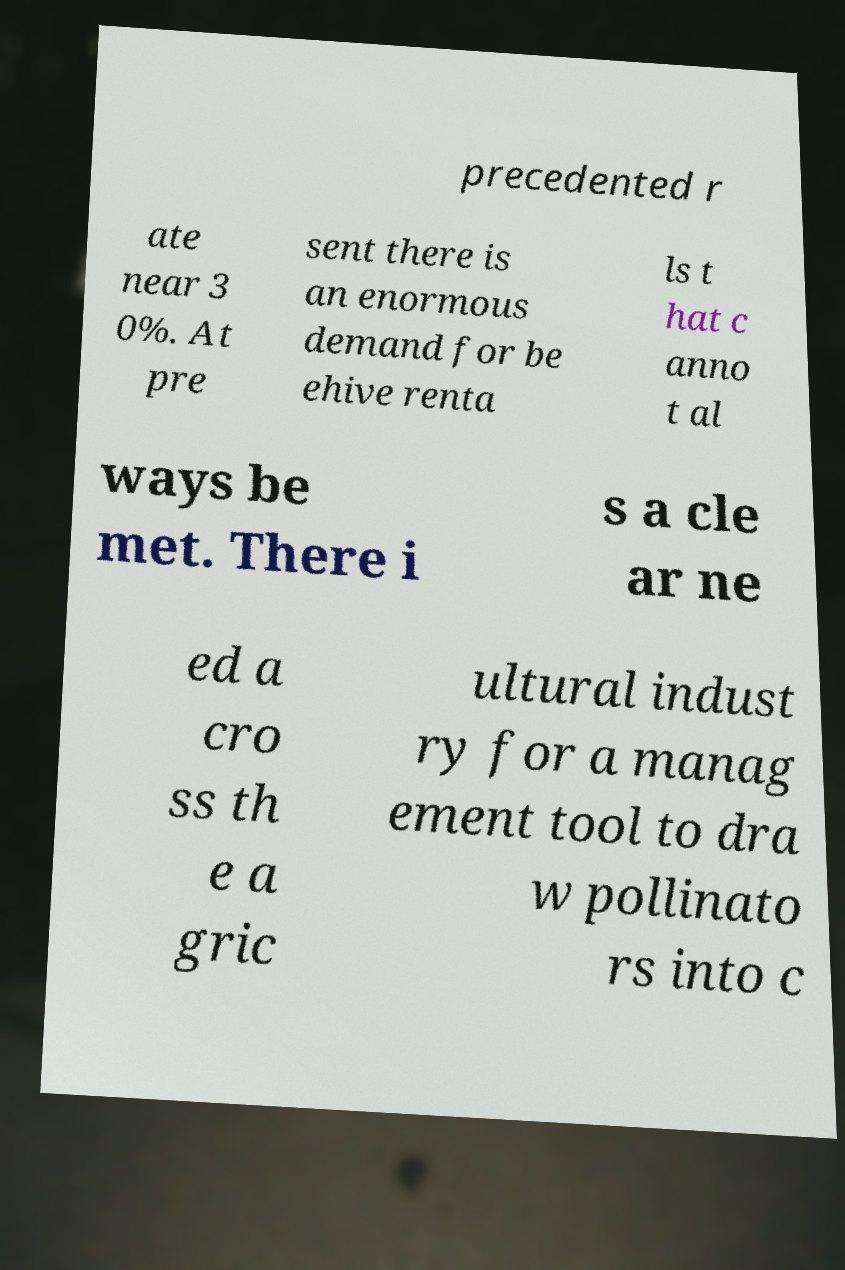Can you accurately transcribe the text from the provided image for me? precedented r ate near 3 0%. At pre sent there is an enormous demand for be ehive renta ls t hat c anno t al ways be met. There i s a cle ar ne ed a cro ss th e a gric ultural indust ry for a manag ement tool to dra w pollinato rs into c 